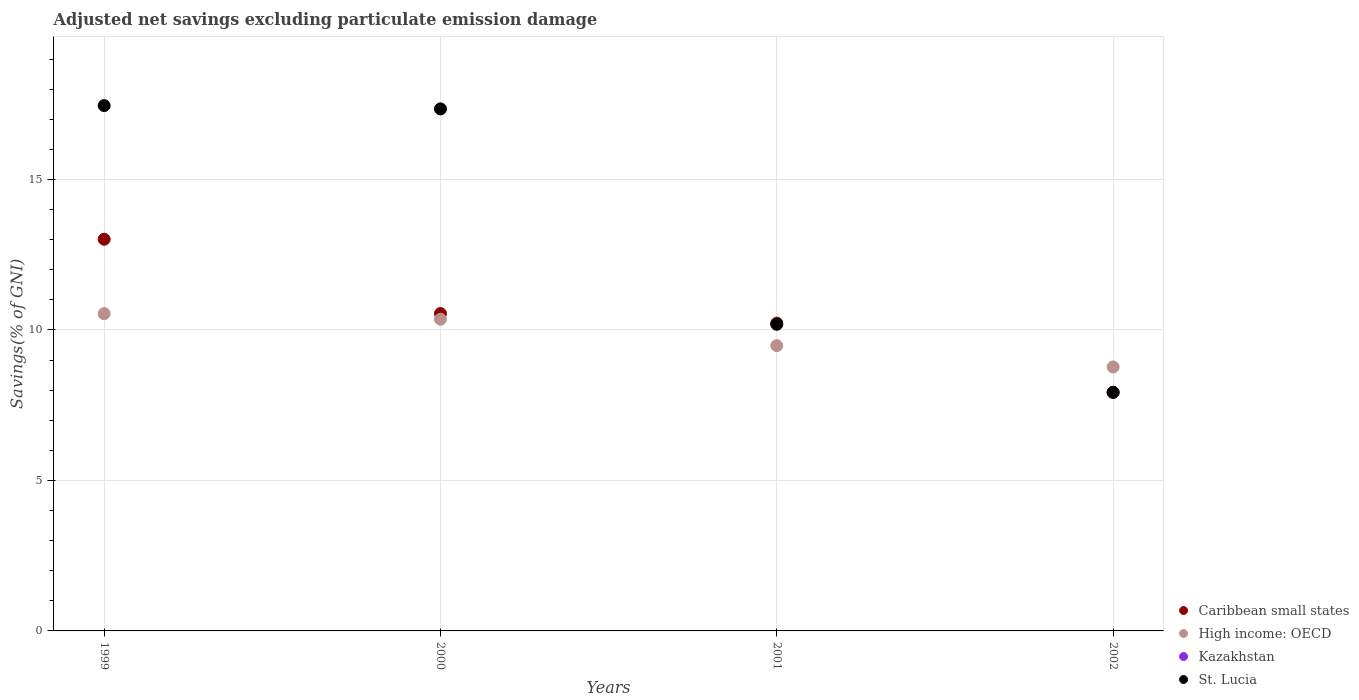Is the number of dotlines equal to the number of legend labels?
Give a very brief answer. No. What is the adjusted net savings in Kazakhstan in 2002?
Provide a succinct answer. 0. Across all years, what is the maximum adjusted net savings in Caribbean small states?
Your answer should be very brief. 13.01. Across all years, what is the minimum adjusted net savings in Kazakhstan?
Make the answer very short. 0. In which year was the adjusted net savings in St. Lucia maximum?
Provide a short and direct response. 1999. What is the total adjusted net savings in Caribbean small states in the graph?
Your answer should be very brief. 41.72. What is the difference between the adjusted net savings in Caribbean small states in 1999 and that in 2001?
Offer a very short reply. 2.79. What is the difference between the adjusted net savings in St. Lucia in 2002 and the adjusted net savings in Caribbean small states in 2000?
Your answer should be very brief. -2.62. What is the average adjusted net savings in St. Lucia per year?
Offer a very short reply. 13.23. In the year 2000, what is the difference between the adjusted net savings in High income: OECD and adjusted net savings in St. Lucia?
Keep it short and to the point. -6.99. What is the ratio of the adjusted net savings in Caribbean small states in 2000 to that in 2001?
Your answer should be very brief. 1.03. Is the adjusted net savings in St. Lucia in 2000 less than that in 2002?
Provide a short and direct response. No. What is the difference between the highest and the second highest adjusted net savings in St. Lucia?
Ensure brevity in your answer.  0.11. What is the difference between the highest and the lowest adjusted net savings in St. Lucia?
Make the answer very short. 9.53. In how many years, is the adjusted net savings in Kazakhstan greater than the average adjusted net savings in Kazakhstan taken over all years?
Your response must be concise. 0. Is the adjusted net savings in Kazakhstan strictly less than the adjusted net savings in St. Lucia over the years?
Your response must be concise. Yes. How many dotlines are there?
Your answer should be very brief. 3. What is the difference between two consecutive major ticks on the Y-axis?
Your answer should be compact. 5. Does the graph contain any zero values?
Your answer should be compact. Yes. Does the graph contain grids?
Your response must be concise. Yes. How are the legend labels stacked?
Offer a very short reply. Vertical. What is the title of the graph?
Provide a short and direct response. Adjusted net savings excluding particulate emission damage. What is the label or title of the Y-axis?
Your answer should be very brief. Savings(% of GNI). What is the Savings(% of GNI) of Caribbean small states in 1999?
Your answer should be very brief. 13.01. What is the Savings(% of GNI) of High income: OECD in 1999?
Make the answer very short. 10.54. What is the Savings(% of GNI) of Kazakhstan in 1999?
Give a very brief answer. 0. What is the Savings(% of GNI) in St. Lucia in 1999?
Provide a succinct answer. 17.46. What is the Savings(% of GNI) in Caribbean small states in 2000?
Offer a terse response. 10.55. What is the Savings(% of GNI) of High income: OECD in 2000?
Provide a succinct answer. 10.36. What is the Savings(% of GNI) of Kazakhstan in 2000?
Ensure brevity in your answer.  0. What is the Savings(% of GNI) in St. Lucia in 2000?
Your answer should be compact. 17.34. What is the Savings(% of GNI) of Caribbean small states in 2001?
Offer a terse response. 10.23. What is the Savings(% of GNI) of High income: OECD in 2001?
Give a very brief answer. 9.48. What is the Savings(% of GNI) of St. Lucia in 2001?
Your answer should be very brief. 10.19. What is the Savings(% of GNI) in Caribbean small states in 2002?
Make the answer very short. 7.93. What is the Savings(% of GNI) in High income: OECD in 2002?
Keep it short and to the point. 8.77. What is the Savings(% of GNI) in Kazakhstan in 2002?
Keep it short and to the point. 0. What is the Savings(% of GNI) in St. Lucia in 2002?
Offer a terse response. 7.93. Across all years, what is the maximum Savings(% of GNI) of Caribbean small states?
Your response must be concise. 13.01. Across all years, what is the maximum Savings(% of GNI) in High income: OECD?
Offer a very short reply. 10.54. Across all years, what is the maximum Savings(% of GNI) in St. Lucia?
Keep it short and to the point. 17.46. Across all years, what is the minimum Savings(% of GNI) in Caribbean small states?
Offer a terse response. 7.93. Across all years, what is the minimum Savings(% of GNI) in High income: OECD?
Your answer should be compact. 8.77. Across all years, what is the minimum Savings(% of GNI) in St. Lucia?
Give a very brief answer. 7.93. What is the total Savings(% of GNI) in Caribbean small states in the graph?
Make the answer very short. 41.72. What is the total Savings(% of GNI) in High income: OECD in the graph?
Keep it short and to the point. 39.15. What is the total Savings(% of GNI) of Kazakhstan in the graph?
Give a very brief answer. 0. What is the total Savings(% of GNI) of St. Lucia in the graph?
Give a very brief answer. 52.92. What is the difference between the Savings(% of GNI) of Caribbean small states in 1999 and that in 2000?
Offer a very short reply. 2.47. What is the difference between the Savings(% of GNI) in High income: OECD in 1999 and that in 2000?
Keep it short and to the point. 0.18. What is the difference between the Savings(% of GNI) in St. Lucia in 1999 and that in 2000?
Provide a succinct answer. 0.11. What is the difference between the Savings(% of GNI) in Caribbean small states in 1999 and that in 2001?
Make the answer very short. 2.79. What is the difference between the Savings(% of GNI) in High income: OECD in 1999 and that in 2001?
Provide a succinct answer. 1.06. What is the difference between the Savings(% of GNI) in St. Lucia in 1999 and that in 2001?
Your answer should be compact. 7.27. What is the difference between the Savings(% of GNI) of Caribbean small states in 1999 and that in 2002?
Ensure brevity in your answer.  5.08. What is the difference between the Savings(% of GNI) in High income: OECD in 1999 and that in 2002?
Offer a terse response. 1.77. What is the difference between the Savings(% of GNI) of St. Lucia in 1999 and that in 2002?
Your answer should be compact. 9.53. What is the difference between the Savings(% of GNI) of Caribbean small states in 2000 and that in 2001?
Make the answer very short. 0.32. What is the difference between the Savings(% of GNI) in High income: OECD in 2000 and that in 2001?
Make the answer very short. 0.88. What is the difference between the Savings(% of GNI) in St. Lucia in 2000 and that in 2001?
Make the answer very short. 7.16. What is the difference between the Savings(% of GNI) in Caribbean small states in 2000 and that in 2002?
Your response must be concise. 2.62. What is the difference between the Savings(% of GNI) in High income: OECD in 2000 and that in 2002?
Your response must be concise. 1.59. What is the difference between the Savings(% of GNI) of St. Lucia in 2000 and that in 2002?
Make the answer very short. 9.42. What is the difference between the Savings(% of GNI) in Caribbean small states in 2001 and that in 2002?
Your response must be concise. 2.3. What is the difference between the Savings(% of GNI) in High income: OECD in 2001 and that in 2002?
Keep it short and to the point. 0.71. What is the difference between the Savings(% of GNI) of St. Lucia in 2001 and that in 2002?
Your answer should be very brief. 2.26. What is the difference between the Savings(% of GNI) of Caribbean small states in 1999 and the Savings(% of GNI) of High income: OECD in 2000?
Give a very brief answer. 2.66. What is the difference between the Savings(% of GNI) in Caribbean small states in 1999 and the Savings(% of GNI) in St. Lucia in 2000?
Provide a succinct answer. -4.33. What is the difference between the Savings(% of GNI) of High income: OECD in 1999 and the Savings(% of GNI) of St. Lucia in 2000?
Keep it short and to the point. -6.8. What is the difference between the Savings(% of GNI) in Caribbean small states in 1999 and the Savings(% of GNI) in High income: OECD in 2001?
Offer a very short reply. 3.54. What is the difference between the Savings(% of GNI) in Caribbean small states in 1999 and the Savings(% of GNI) in St. Lucia in 2001?
Your answer should be compact. 2.83. What is the difference between the Savings(% of GNI) of High income: OECD in 1999 and the Savings(% of GNI) of St. Lucia in 2001?
Make the answer very short. 0.35. What is the difference between the Savings(% of GNI) of Caribbean small states in 1999 and the Savings(% of GNI) of High income: OECD in 2002?
Ensure brevity in your answer.  4.24. What is the difference between the Savings(% of GNI) in Caribbean small states in 1999 and the Savings(% of GNI) in St. Lucia in 2002?
Your answer should be very brief. 5.09. What is the difference between the Savings(% of GNI) of High income: OECD in 1999 and the Savings(% of GNI) of St. Lucia in 2002?
Make the answer very short. 2.61. What is the difference between the Savings(% of GNI) in Caribbean small states in 2000 and the Savings(% of GNI) in High income: OECD in 2001?
Your answer should be compact. 1.07. What is the difference between the Savings(% of GNI) in Caribbean small states in 2000 and the Savings(% of GNI) in St. Lucia in 2001?
Make the answer very short. 0.36. What is the difference between the Savings(% of GNI) of High income: OECD in 2000 and the Savings(% of GNI) of St. Lucia in 2001?
Offer a very short reply. 0.17. What is the difference between the Savings(% of GNI) in Caribbean small states in 2000 and the Savings(% of GNI) in High income: OECD in 2002?
Ensure brevity in your answer.  1.78. What is the difference between the Savings(% of GNI) of Caribbean small states in 2000 and the Savings(% of GNI) of St. Lucia in 2002?
Give a very brief answer. 2.62. What is the difference between the Savings(% of GNI) in High income: OECD in 2000 and the Savings(% of GNI) in St. Lucia in 2002?
Keep it short and to the point. 2.43. What is the difference between the Savings(% of GNI) in Caribbean small states in 2001 and the Savings(% of GNI) in High income: OECD in 2002?
Your response must be concise. 1.46. What is the difference between the Savings(% of GNI) in Caribbean small states in 2001 and the Savings(% of GNI) in St. Lucia in 2002?
Provide a short and direct response. 2.3. What is the difference between the Savings(% of GNI) in High income: OECD in 2001 and the Savings(% of GNI) in St. Lucia in 2002?
Your response must be concise. 1.55. What is the average Savings(% of GNI) of Caribbean small states per year?
Provide a succinct answer. 10.43. What is the average Savings(% of GNI) of High income: OECD per year?
Provide a succinct answer. 9.79. What is the average Savings(% of GNI) of Kazakhstan per year?
Provide a short and direct response. 0. What is the average Savings(% of GNI) in St. Lucia per year?
Give a very brief answer. 13.23. In the year 1999, what is the difference between the Savings(% of GNI) in Caribbean small states and Savings(% of GNI) in High income: OECD?
Ensure brevity in your answer.  2.47. In the year 1999, what is the difference between the Savings(% of GNI) of Caribbean small states and Savings(% of GNI) of St. Lucia?
Keep it short and to the point. -4.44. In the year 1999, what is the difference between the Savings(% of GNI) in High income: OECD and Savings(% of GNI) in St. Lucia?
Keep it short and to the point. -6.91. In the year 2000, what is the difference between the Savings(% of GNI) in Caribbean small states and Savings(% of GNI) in High income: OECD?
Offer a very short reply. 0.19. In the year 2000, what is the difference between the Savings(% of GNI) in Caribbean small states and Savings(% of GNI) in St. Lucia?
Your answer should be compact. -6.8. In the year 2000, what is the difference between the Savings(% of GNI) in High income: OECD and Savings(% of GNI) in St. Lucia?
Make the answer very short. -6.99. In the year 2001, what is the difference between the Savings(% of GNI) of Caribbean small states and Savings(% of GNI) of High income: OECD?
Make the answer very short. 0.75. In the year 2001, what is the difference between the Savings(% of GNI) in Caribbean small states and Savings(% of GNI) in St. Lucia?
Offer a terse response. 0.04. In the year 2001, what is the difference between the Savings(% of GNI) in High income: OECD and Savings(% of GNI) in St. Lucia?
Offer a terse response. -0.71. In the year 2002, what is the difference between the Savings(% of GNI) of Caribbean small states and Savings(% of GNI) of High income: OECD?
Your answer should be very brief. -0.84. In the year 2002, what is the difference between the Savings(% of GNI) in Caribbean small states and Savings(% of GNI) in St. Lucia?
Provide a short and direct response. 0. In the year 2002, what is the difference between the Savings(% of GNI) in High income: OECD and Savings(% of GNI) in St. Lucia?
Keep it short and to the point. 0.84. What is the ratio of the Savings(% of GNI) in Caribbean small states in 1999 to that in 2000?
Make the answer very short. 1.23. What is the ratio of the Savings(% of GNI) in High income: OECD in 1999 to that in 2000?
Make the answer very short. 1.02. What is the ratio of the Savings(% of GNI) of St. Lucia in 1999 to that in 2000?
Offer a very short reply. 1.01. What is the ratio of the Savings(% of GNI) of Caribbean small states in 1999 to that in 2001?
Your answer should be very brief. 1.27. What is the ratio of the Savings(% of GNI) of High income: OECD in 1999 to that in 2001?
Offer a terse response. 1.11. What is the ratio of the Savings(% of GNI) in St. Lucia in 1999 to that in 2001?
Keep it short and to the point. 1.71. What is the ratio of the Savings(% of GNI) of Caribbean small states in 1999 to that in 2002?
Make the answer very short. 1.64. What is the ratio of the Savings(% of GNI) in High income: OECD in 1999 to that in 2002?
Keep it short and to the point. 1.2. What is the ratio of the Savings(% of GNI) in St. Lucia in 1999 to that in 2002?
Your response must be concise. 2.2. What is the ratio of the Savings(% of GNI) in Caribbean small states in 2000 to that in 2001?
Provide a short and direct response. 1.03. What is the ratio of the Savings(% of GNI) of High income: OECD in 2000 to that in 2001?
Offer a very short reply. 1.09. What is the ratio of the Savings(% of GNI) of St. Lucia in 2000 to that in 2001?
Offer a terse response. 1.7. What is the ratio of the Savings(% of GNI) in Caribbean small states in 2000 to that in 2002?
Offer a terse response. 1.33. What is the ratio of the Savings(% of GNI) of High income: OECD in 2000 to that in 2002?
Your answer should be very brief. 1.18. What is the ratio of the Savings(% of GNI) in St. Lucia in 2000 to that in 2002?
Your answer should be very brief. 2.19. What is the ratio of the Savings(% of GNI) in Caribbean small states in 2001 to that in 2002?
Offer a terse response. 1.29. What is the ratio of the Savings(% of GNI) in High income: OECD in 2001 to that in 2002?
Give a very brief answer. 1.08. What is the ratio of the Savings(% of GNI) in St. Lucia in 2001 to that in 2002?
Your answer should be very brief. 1.29. What is the difference between the highest and the second highest Savings(% of GNI) in Caribbean small states?
Your answer should be very brief. 2.47. What is the difference between the highest and the second highest Savings(% of GNI) of High income: OECD?
Give a very brief answer. 0.18. What is the difference between the highest and the second highest Savings(% of GNI) in St. Lucia?
Your answer should be very brief. 0.11. What is the difference between the highest and the lowest Savings(% of GNI) in Caribbean small states?
Your response must be concise. 5.08. What is the difference between the highest and the lowest Savings(% of GNI) of High income: OECD?
Offer a very short reply. 1.77. What is the difference between the highest and the lowest Savings(% of GNI) of St. Lucia?
Your answer should be compact. 9.53. 